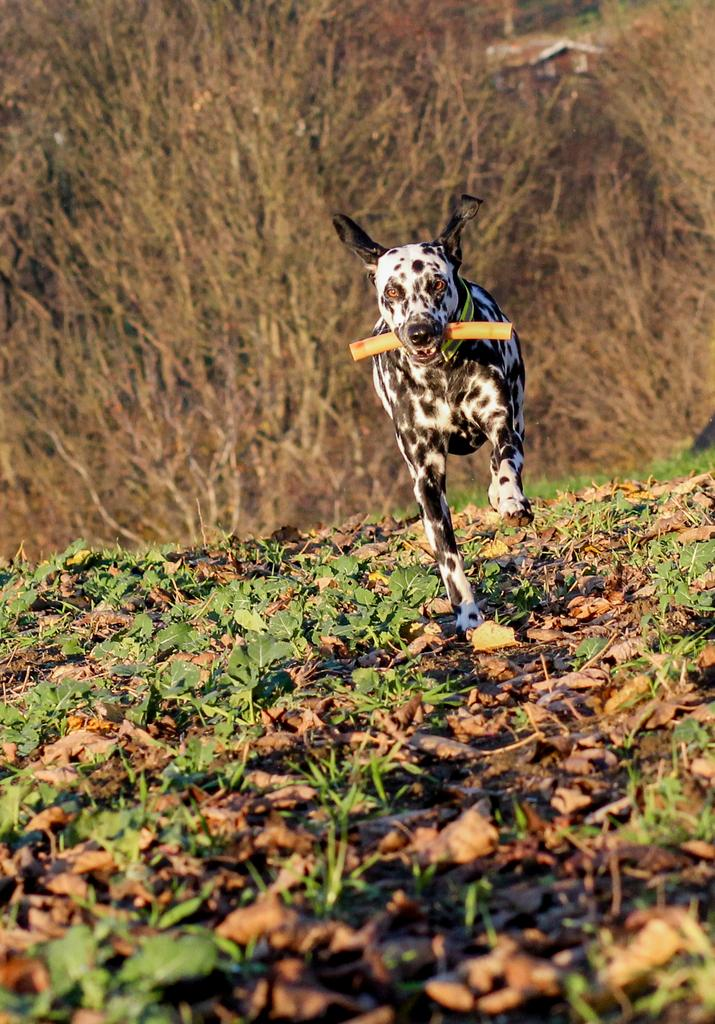What animal can be seen in the image? There is a dog in the image. What is the dog doing in the image? The dog is holding something with its mouth. Where is the dog located in the image? The dog is standing on the ground. What type of vegetation is present on the ground? There are plants on the ground. What activity is the wren participating in with its partner in the image? There is no wren or partner present in the image; it features a dog holding something with its mouth. 